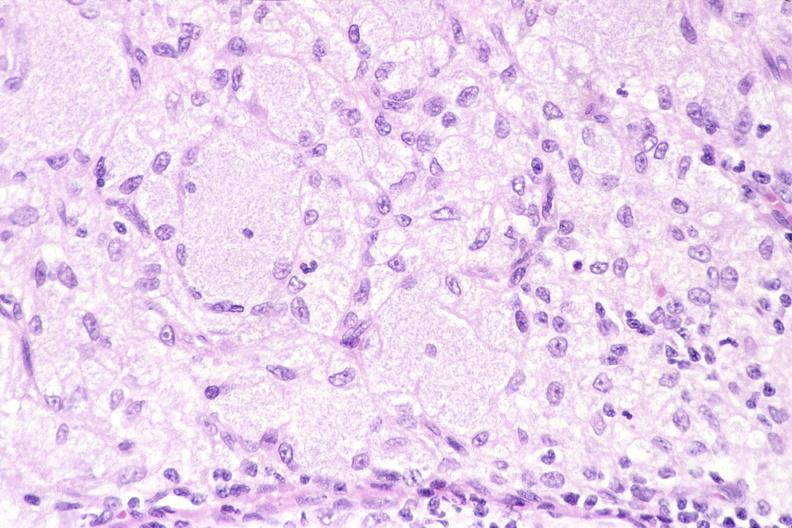does capillary show lymph node, mycobacterium avium-intracellularae?
Answer the question using a single word or phrase. No 